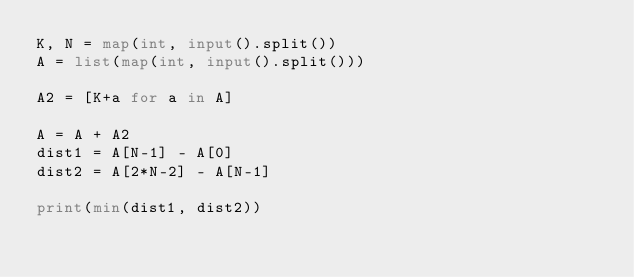<code> <loc_0><loc_0><loc_500><loc_500><_Python_>K, N = map(int, input().split())
A = list(map(int, input().split()))

A2 = [K+a for a in A]

A = A + A2
dist1 = A[N-1] - A[0]
dist2 = A[2*N-2] - A[N-1]

print(min(dist1, dist2))
</code> 